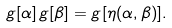<formula> <loc_0><loc_0><loc_500><loc_500>g [ \alpha ] \, g [ \beta ] = g [ \eta ( \alpha , \beta ) ] .</formula> 